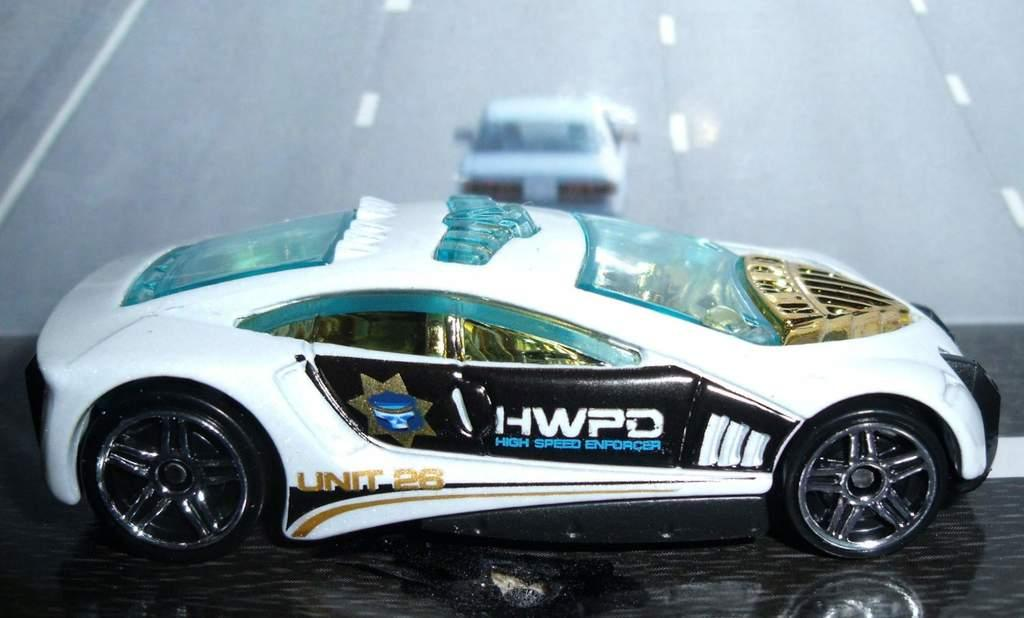What type of toy is present in the image? There is a toy car in the image. Where is the toy car located? The toy car is placed on a platform. What can be seen in the background of the image? There is a road visible in the background of the image. What else is present on the road in the background? There are vehicles on the road in the background. How much payment is required to use the honey in the image? There is no honey present in the image, so payment is not applicable. 